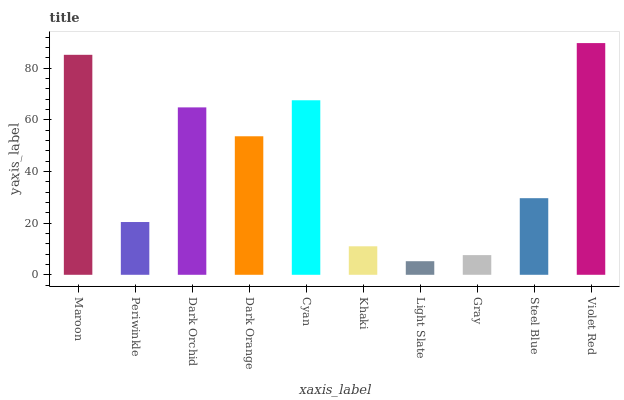Is Light Slate the minimum?
Answer yes or no. Yes. Is Violet Red the maximum?
Answer yes or no. Yes. Is Periwinkle the minimum?
Answer yes or no. No. Is Periwinkle the maximum?
Answer yes or no. No. Is Maroon greater than Periwinkle?
Answer yes or no. Yes. Is Periwinkle less than Maroon?
Answer yes or no. Yes. Is Periwinkle greater than Maroon?
Answer yes or no. No. Is Maroon less than Periwinkle?
Answer yes or no. No. Is Dark Orange the high median?
Answer yes or no. Yes. Is Steel Blue the low median?
Answer yes or no. Yes. Is Maroon the high median?
Answer yes or no. No. Is Violet Red the low median?
Answer yes or no. No. 